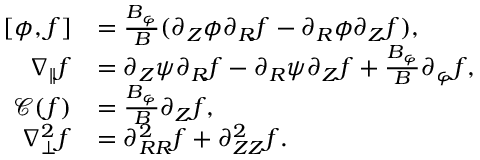<formula> <loc_0><loc_0><loc_500><loc_500>\begin{array} { r l } { [ \phi , f ] } & { = \frac { B _ { \varphi } } { B } ( \partial _ { Z } \phi \partial _ { R } f - \partial _ { R } \phi \partial _ { Z } f ) , } \\ { \nabla _ { \| } f } & { = \partial _ { Z } \psi \partial _ { R } f - \partial _ { R } \psi \partial _ { Z } f + \frac { B _ { \varphi } } { B } \partial _ { \varphi } f , } \\ { \mathcal { C } ( f ) } & { = \frac { B _ { \varphi } } { B } \partial _ { Z } f , } \\ { \nabla _ { \perp } ^ { 2 } f } & { = \partial _ { R R } ^ { 2 } f + \partial _ { Z Z } ^ { 2 } f . } \end{array}</formula> 